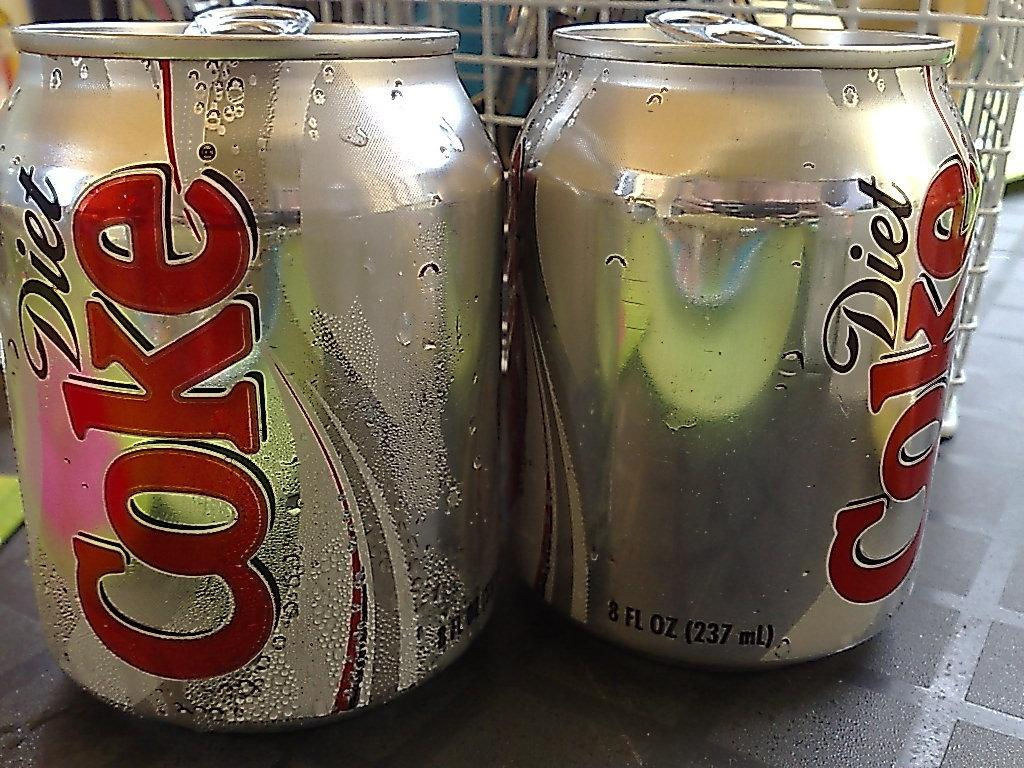Provide a one-sentence caption for the provided image. Two 8 FL OZ cans of Diet Coke. 